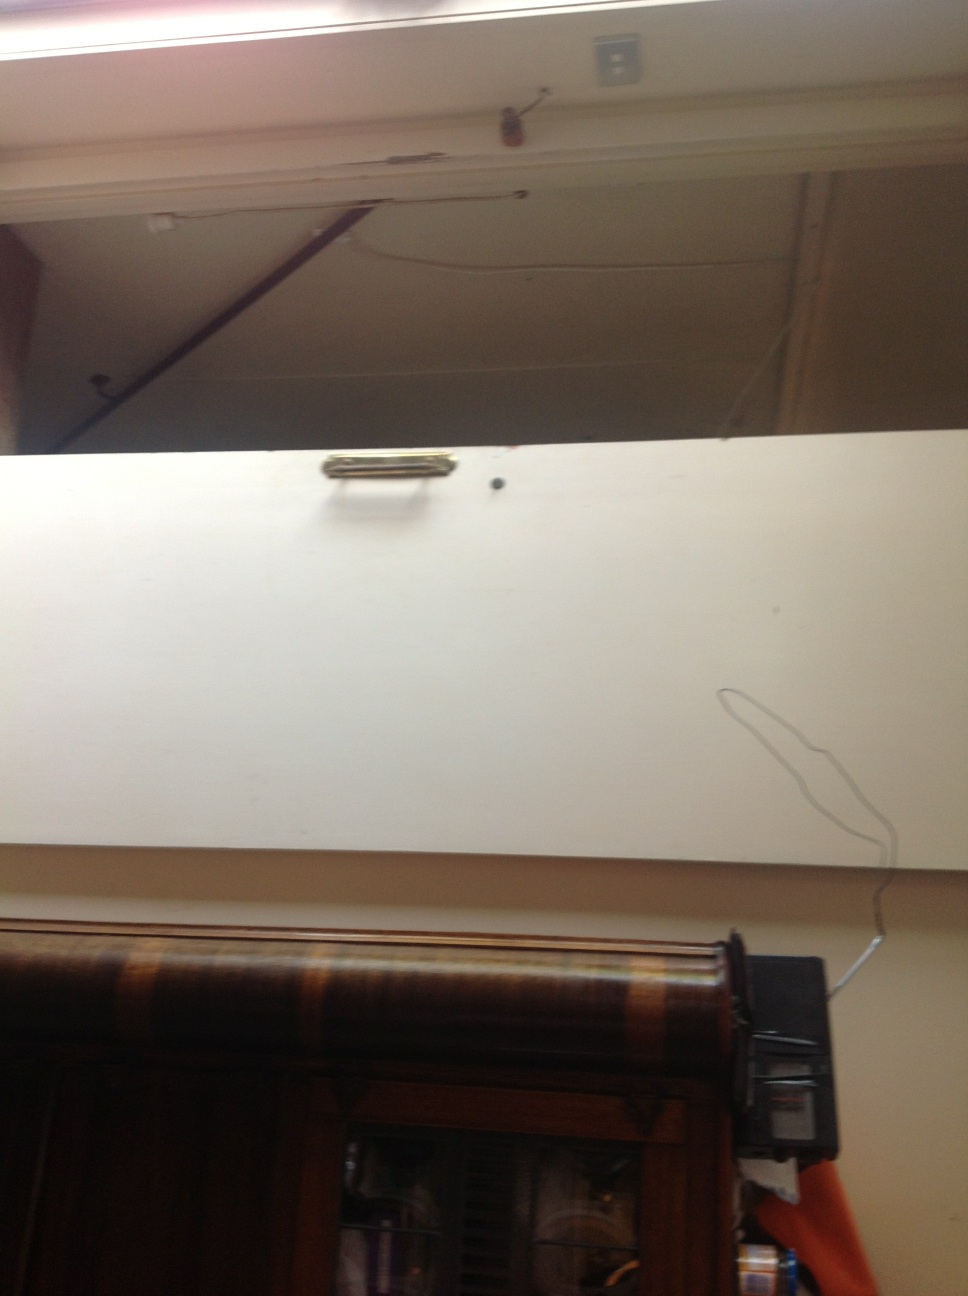How does the door's design complement the interior decor seen in the image? The door's minimalistic design, with its clean white surface and contrasting brown frame, provides a sense of simplicity and order within the space. This style aligns with the utilitarian and uncluttered look of the overhead space and barely-visible furnishings. 